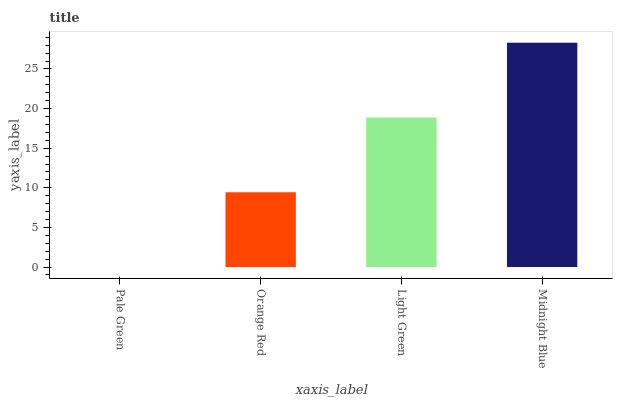Is Orange Red the minimum?
Answer yes or no. No. Is Orange Red the maximum?
Answer yes or no. No. Is Orange Red greater than Pale Green?
Answer yes or no. Yes. Is Pale Green less than Orange Red?
Answer yes or no. Yes. Is Pale Green greater than Orange Red?
Answer yes or no. No. Is Orange Red less than Pale Green?
Answer yes or no. No. Is Light Green the high median?
Answer yes or no. Yes. Is Orange Red the low median?
Answer yes or no. Yes. Is Orange Red the high median?
Answer yes or no. No. Is Midnight Blue the low median?
Answer yes or no. No. 